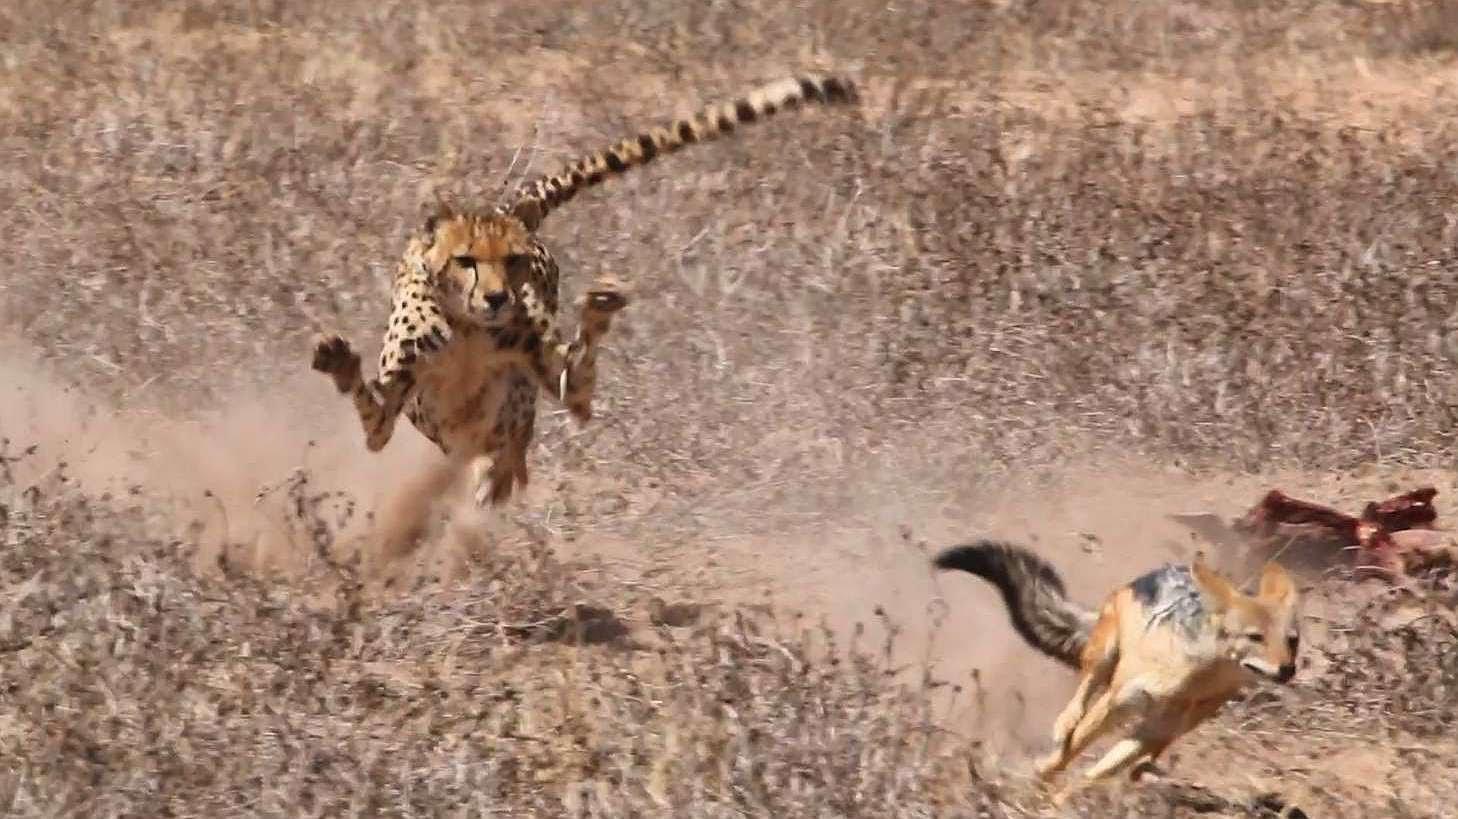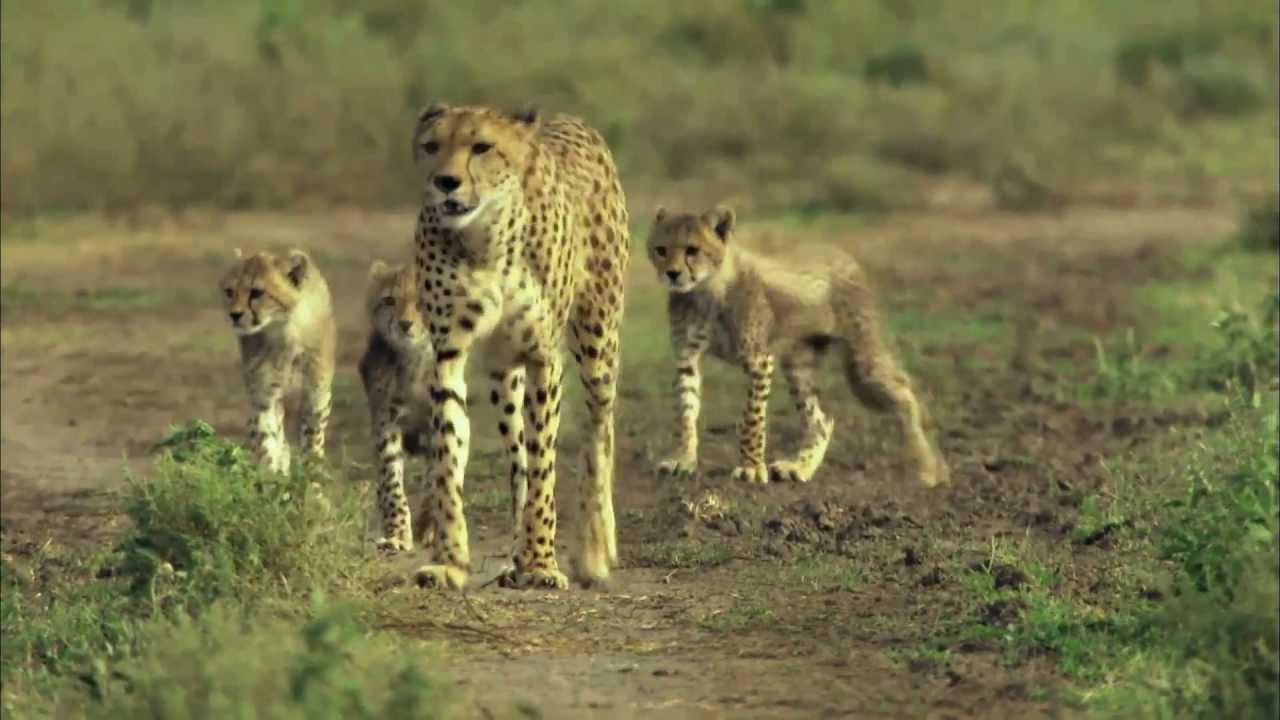The first image is the image on the left, the second image is the image on the right. Given the left and right images, does the statement "A single cheetah is chasing after a single prey in each image." hold true? Answer yes or no. No. The first image is the image on the left, the second image is the image on the right. Analyze the images presented: Is the assertion "All cheetahs appear to be actively chasing adult gazelles." valid? Answer yes or no. No. 